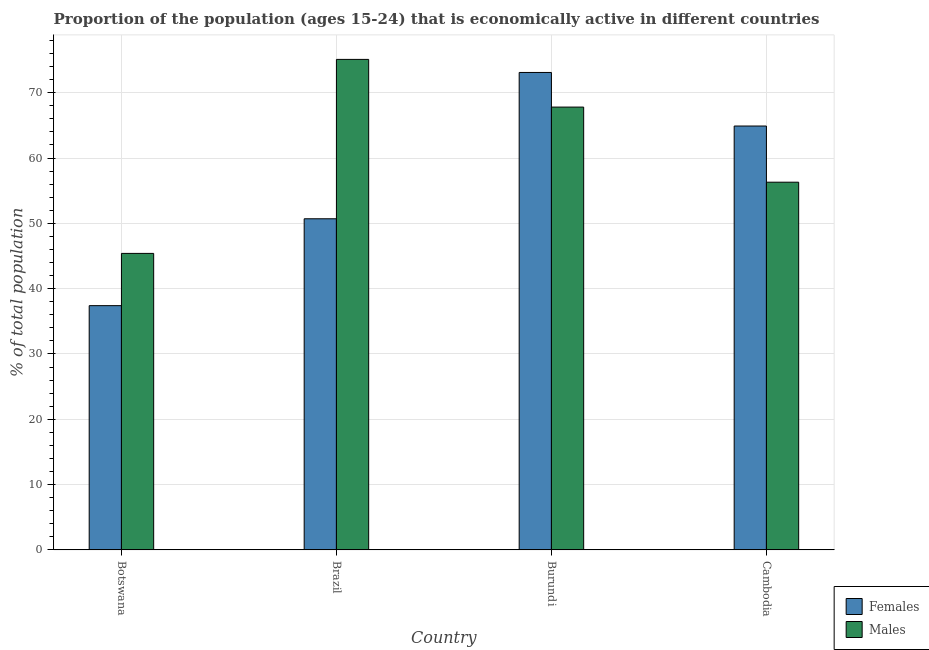Are the number of bars per tick equal to the number of legend labels?
Offer a terse response. Yes. Are the number of bars on each tick of the X-axis equal?
Offer a terse response. Yes. What is the percentage of economically active male population in Cambodia?
Provide a short and direct response. 56.3. Across all countries, what is the maximum percentage of economically active male population?
Your answer should be very brief. 75.1. Across all countries, what is the minimum percentage of economically active female population?
Give a very brief answer. 37.4. In which country was the percentage of economically active female population maximum?
Your answer should be very brief. Burundi. In which country was the percentage of economically active male population minimum?
Give a very brief answer. Botswana. What is the total percentage of economically active female population in the graph?
Make the answer very short. 226.1. What is the difference between the percentage of economically active female population in Botswana and that in Brazil?
Offer a very short reply. -13.3. What is the difference between the percentage of economically active female population in Cambodia and the percentage of economically active male population in Botswana?
Offer a very short reply. 19.5. What is the average percentage of economically active female population per country?
Ensure brevity in your answer.  56.53. What is the difference between the percentage of economically active male population and percentage of economically active female population in Burundi?
Give a very brief answer. -5.3. In how many countries, is the percentage of economically active female population greater than 18 %?
Provide a short and direct response. 4. What is the ratio of the percentage of economically active female population in Botswana to that in Cambodia?
Your response must be concise. 0.58. Is the percentage of economically active female population in Brazil less than that in Burundi?
Offer a terse response. Yes. Is the difference between the percentage of economically active female population in Botswana and Cambodia greater than the difference between the percentage of economically active male population in Botswana and Cambodia?
Provide a succinct answer. No. What is the difference between the highest and the second highest percentage of economically active male population?
Give a very brief answer. 7.3. What is the difference between the highest and the lowest percentage of economically active female population?
Offer a terse response. 35.7. Is the sum of the percentage of economically active female population in Burundi and Cambodia greater than the maximum percentage of economically active male population across all countries?
Ensure brevity in your answer.  Yes. What does the 2nd bar from the left in Brazil represents?
Your response must be concise. Males. What does the 1st bar from the right in Cambodia represents?
Your answer should be very brief. Males. How many bars are there?
Offer a terse response. 8. How many countries are there in the graph?
Provide a succinct answer. 4. Are the values on the major ticks of Y-axis written in scientific E-notation?
Your answer should be compact. No. Does the graph contain any zero values?
Your answer should be very brief. No. Does the graph contain grids?
Provide a succinct answer. Yes. What is the title of the graph?
Keep it short and to the point. Proportion of the population (ages 15-24) that is economically active in different countries. Does "Net savings(excluding particulate emission damage)" appear as one of the legend labels in the graph?
Keep it short and to the point. No. What is the label or title of the Y-axis?
Provide a succinct answer. % of total population. What is the % of total population in Females in Botswana?
Provide a succinct answer. 37.4. What is the % of total population of Males in Botswana?
Offer a terse response. 45.4. What is the % of total population in Females in Brazil?
Provide a short and direct response. 50.7. What is the % of total population of Males in Brazil?
Your answer should be very brief. 75.1. What is the % of total population of Females in Burundi?
Keep it short and to the point. 73.1. What is the % of total population of Males in Burundi?
Provide a short and direct response. 67.8. What is the % of total population in Females in Cambodia?
Make the answer very short. 64.9. What is the % of total population of Males in Cambodia?
Offer a terse response. 56.3. Across all countries, what is the maximum % of total population in Females?
Keep it short and to the point. 73.1. Across all countries, what is the maximum % of total population of Males?
Give a very brief answer. 75.1. Across all countries, what is the minimum % of total population in Females?
Your answer should be very brief. 37.4. Across all countries, what is the minimum % of total population of Males?
Keep it short and to the point. 45.4. What is the total % of total population of Females in the graph?
Make the answer very short. 226.1. What is the total % of total population in Males in the graph?
Offer a terse response. 244.6. What is the difference between the % of total population in Males in Botswana and that in Brazil?
Your response must be concise. -29.7. What is the difference between the % of total population in Females in Botswana and that in Burundi?
Keep it short and to the point. -35.7. What is the difference between the % of total population of Males in Botswana and that in Burundi?
Your response must be concise. -22.4. What is the difference between the % of total population in Females in Botswana and that in Cambodia?
Keep it short and to the point. -27.5. What is the difference between the % of total population of Females in Brazil and that in Burundi?
Your answer should be compact. -22.4. What is the difference between the % of total population in Males in Brazil and that in Burundi?
Your answer should be compact. 7.3. What is the difference between the % of total population of Females in Brazil and that in Cambodia?
Provide a short and direct response. -14.2. What is the difference between the % of total population of Males in Brazil and that in Cambodia?
Keep it short and to the point. 18.8. What is the difference between the % of total population in Females in Burundi and that in Cambodia?
Provide a succinct answer. 8.2. What is the difference between the % of total population in Females in Botswana and the % of total population in Males in Brazil?
Ensure brevity in your answer.  -37.7. What is the difference between the % of total population of Females in Botswana and the % of total population of Males in Burundi?
Your answer should be very brief. -30.4. What is the difference between the % of total population of Females in Botswana and the % of total population of Males in Cambodia?
Your response must be concise. -18.9. What is the difference between the % of total population of Females in Brazil and the % of total population of Males in Burundi?
Your answer should be very brief. -17.1. What is the difference between the % of total population of Females in Brazil and the % of total population of Males in Cambodia?
Your answer should be very brief. -5.6. What is the difference between the % of total population in Females in Burundi and the % of total population in Males in Cambodia?
Provide a short and direct response. 16.8. What is the average % of total population of Females per country?
Offer a very short reply. 56.52. What is the average % of total population in Males per country?
Provide a succinct answer. 61.15. What is the difference between the % of total population of Females and % of total population of Males in Botswana?
Keep it short and to the point. -8. What is the difference between the % of total population in Females and % of total population in Males in Brazil?
Your response must be concise. -24.4. What is the ratio of the % of total population of Females in Botswana to that in Brazil?
Your answer should be compact. 0.74. What is the ratio of the % of total population in Males in Botswana to that in Brazil?
Your answer should be compact. 0.6. What is the ratio of the % of total population in Females in Botswana to that in Burundi?
Your answer should be very brief. 0.51. What is the ratio of the % of total population of Males in Botswana to that in Burundi?
Offer a terse response. 0.67. What is the ratio of the % of total population of Females in Botswana to that in Cambodia?
Give a very brief answer. 0.58. What is the ratio of the % of total population of Males in Botswana to that in Cambodia?
Your answer should be very brief. 0.81. What is the ratio of the % of total population in Females in Brazil to that in Burundi?
Your answer should be very brief. 0.69. What is the ratio of the % of total population in Males in Brazil to that in Burundi?
Give a very brief answer. 1.11. What is the ratio of the % of total population in Females in Brazil to that in Cambodia?
Your response must be concise. 0.78. What is the ratio of the % of total population in Males in Brazil to that in Cambodia?
Your answer should be very brief. 1.33. What is the ratio of the % of total population in Females in Burundi to that in Cambodia?
Your answer should be very brief. 1.13. What is the ratio of the % of total population of Males in Burundi to that in Cambodia?
Your answer should be compact. 1.2. What is the difference between the highest and the second highest % of total population of Females?
Provide a succinct answer. 8.2. What is the difference between the highest and the lowest % of total population in Females?
Keep it short and to the point. 35.7. What is the difference between the highest and the lowest % of total population of Males?
Offer a very short reply. 29.7. 